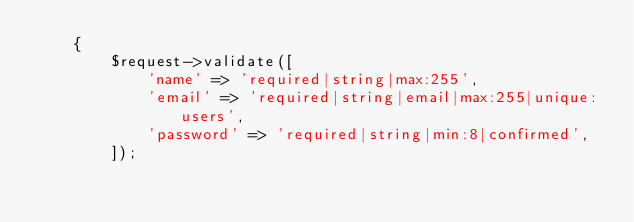<code> <loc_0><loc_0><loc_500><loc_500><_PHP_>    {
        $request->validate([
            'name' => 'required|string|max:255',
            'email' => 'required|string|email|max:255|unique:users',
            'password' => 'required|string|min:8|confirmed',
        ]);
</code> 